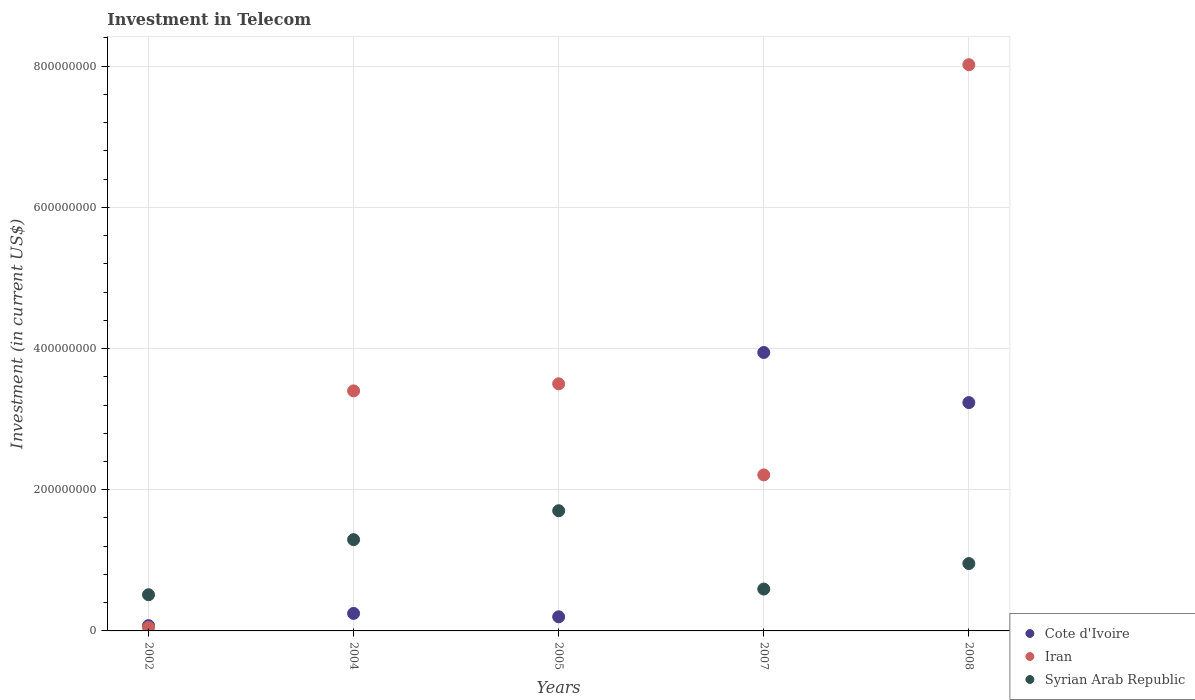How many different coloured dotlines are there?
Your response must be concise. 3. Is the number of dotlines equal to the number of legend labels?
Your answer should be compact. Yes. What is the amount invested in telecom in Cote d'Ivoire in 2002?
Your answer should be very brief. 7.50e+06. Across all years, what is the maximum amount invested in telecom in Iran?
Offer a terse response. 8.02e+08. In which year was the amount invested in telecom in Cote d'Ivoire maximum?
Ensure brevity in your answer.  2007. In which year was the amount invested in telecom in Cote d'Ivoire minimum?
Your response must be concise. 2002. What is the total amount invested in telecom in Syrian Arab Republic in the graph?
Provide a short and direct response. 5.05e+08. What is the difference between the amount invested in telecom in Syrian Arab Republic in 2004 and that in 2005?
Your answer should be compact. -4.10e+07. What is the difference between the amount invested in telecom in Iran in 2004 and the amount invested in telecom in Cote d'Ivoire in 2007?
Provide a short and direct response. -5.44e+07. What is the average amount invested in telecom in Iran per year?
Make the answer very short. 3.44e+08. In the year 2004, what is the difference between the amount invested in telecom in Syrian Arab Republic and amount invested in telecom in Cote d'Ivoire?
Provide a succinct answer. 1.04e+08. In how many years, is the amount invested in telecom in Iran greater than 440000000 US$?
Your answer should be compact. 1. What is the ratio of the amount invested in telecom in Iran in 2005 to that in 2007?
Your answer should be compact. 1.58. Is the amount invested in telecom in Iran in 2002 less than that in 2005?
Offer a terse response. Yes. Is the difference between the amount invested in telecom in Syrian Arab Republic in 2007 and 2008 greater than the difference between the amount invested in telecom in Cote d'Ivoire in 2007 and 2008?
Your answer should be compact. No. What is the difference between the highest and the second highest amount invested in telecom in Iran?
Give a very brief answer. 4.52e+08. What is the difference between the highest and the lowest amount invested in telecom in Cote d'Ivoire?
Your response must be concise. 3.87e+08. Is the sum of the amount invested in telecom in Cote d'Ivoire in 2005 and 2007 greater than the maximum amount invested in telecom in Syrian Arab Republic across all years?
Your response must be concise. Yes. Is it the case that in every year, the sum of the amount invested in telecom in Syrian Arab Republic and amount invested in telecom in Cote d'Ivoire  is greater than the amount invested in telecom in Iran?
Make the answer very short. No. Does the amount invested in telecom in Syrian Arab Republic monotonically increase over the years?
Keep it short and to the point. No. Is the amount invested in telecom in Syrian Arab Republic strictly less than the amount invested in telecom in Iran over the years?
Give a very brief answer. No. How many dotlines are there?
Provide a succinct answer. 3. How many years are there in the graph?
Offer a terse response. 5. Does the graph contain any zero values?
Give a very brief answer. No. Does the graph contain grids?
Your answer should be very brief. Yes. How many legend labels are there?
Give a very brief answer. 3. What is the title of the graph?
Make the answer very short. Investment in Telecom. What is the label or title of the Y-axis?
Offer a very short reply. Investment (in current US$). What is the Investment (in current US$) of Cote d'Ivoire in 2002?
Provide a succinct answer. 7.50e+06. What is the Investment (in current US$) of Syrian Arab Republic in 2002?
Ensure brevity in your answer.  5.12e+07. What is the Investment (in current US$) in Cote d'Ivoire in 2004?
Keep it short and to the point. 2.48e+07. What is the Investment (in current US$) of Iran in 2004?
Provide a short and direct response. 3.40e+08. What is the Investment (in current US$) of Syrian Arab Republic in 2004?
Provide a succinct answer. 1.29e+08. What is the Investment (in current US$) of Cote d'Ivoire in 2005?
Your answer should be very brief. 2.00e+07. What is the Investment (in current US$) of Iran in 2005?
Make the answer very short. 3.50e+08. What is the Investment (in current US$) of Syrian Arab Republic in 2005?
Provide a succinct answer. 1.70e+08. What is the Investment (in current US$) of Cote d'Ivoire in 2007?
Ensure brevity in your answer.  3.94e+08. What is the Investment (in current US$) in Iran in 2007?
Provide a succinct answer. 2.21e+08. What is the Investment (in current US$) of Syrian Arab Republic in 2007?
Your answer should be very brief. 5.93e+07. What is the Investment (in current US$) of Cote d'Ivoire in 2008?
Ensure brevity in your answer.  3.23e+08. What is the Investment (in current US$) in Iran in 2008?
Ensure brevity in your answer.  8.02e+08. What is the Investment (in current US$) of Syrian Arab Republic in 2008?
Ensure brevity in your answer.  9.54e+07. Across all years, what is the maximum Investment (in current US$) of Cote d'Ivoire?
Provide a short and direct response. 3.94e+08. Across all years, what is the maximum Investment (in current US$) of Iran?
Give a very brief answer. 8.02e+08. Across all years, what is the maximum Investment (in current US$) in Syrian Arab Republic?
Provide a succinct answer. 1.70e+08. Across all years, what is the minimum Investment (in current US$) in Cote d'Ivoire?
Your response must be concise. 7.50e+06. Across all years, what is the minimum Investment (in current US$) in Iran?
Your answer should be very brief. 5.00e+06. Across all years, what is the minimum Investment (in current US$) of Syrian Arab Republic?
Ensure brevity in your answer.  5.12e+07. What is the total Investment (in current US$) in Cote d'Ivoire in the graph?
Provide a succinct answer. 7.70e+08. What is the total Investment (in current US$) in Iran in the graph?
Make the answer very short. 1.72e+09. What is the total Investment (in current US$) in Syrian Arab Republic in the graph?
Offer a terse response. 5.05e+08. What is the difference between the Investment (in current US$) in Cote d'Ivoire in 2002 and that in 2004?
Your answer should be compact. -1.73e+07. What is the difference between the Investment (in current US$) of Iran in 2002 and that in 2004?
Your answer should be very brief. -3.35e+08. What is the difference between the Investment (in current US$) in Syrian Arab Republic in 2002 and that in 2004?
Provide a succinct answer. -7.80e+07. What is the difference between the Investment (in current US$) in Cote d'Ivoire in 2002 and that in 2005?
Offer a very short reply. -1.25e+07. What is the difference between the Investment (in current US$) of Iran in 2002 and that in 2005?
Your answer should be compact. -3.45e+08. What is the difference between the Investment (in current US$) in Syrian Arab Republic in 2002 and that in 2005?
Give a very brief answer. -1.19e+08. What is the difference between the Investment (in current US$) in Cote d'Ivoire in 2002 and that in 2007?
Provide a succinct answer. -3.87e+08. What is the difference between the Investment (in current US$) of Iran in 2002 and that in 2007?
Offer a very short reply. -2.16e+08. What is the difference between the Investment (in current US$) in Syrian Arab Republic in 2002 and that in 2007?
Give a very brief answer. -8.05e+06. What is the difference between the Investment (in current US$) in Cote d'Ivoire in 2002 and that in 2008?
Your answer should be very brief. -3.16e+08. What is the difference between the Investment (in current US$) in Iran in 2002 and that in 2008?
Ensure brevity in your answer.  -7.97e+08. What is the difference between the Investment (in current US$) in Syrian Arab Republic in 2002 and that in 2008?
Make the answer very short. -4.42e+07. What is the difference between the Investment (in current US$) in Cote d'Ivoire in 2004 and that in 2005?
Your answer should be very brief. 4.80e+06. What is the difference between the Investment (in current US$) of Iran in 2004 and that in 2005?
Offer a very short reply. -1.00e+07. What is the difference between the Investment (in current US$) in Syrian Arab Republic in 2004 and that in 2005?
Give a very brief answer. -4.10e+07. What is the difference between the Investment (in current US$) in Cote d'Ivoire in 2004 and that in 2007?
Provide a succinct answer. -3.70e+08. What is the difference between the Investment (in current US$) of Iran in 2004 and that in 2007?
Offer a terse response. 1.19e+08. What is the difference between the Investment (in current US$) in Syrian Arab Republic in 2004 and that in 2007?
Your answer should be very brief. 7.00e+07. What is the difference between the Investment (in current US$) of Cote d'Ivoire in 2004 and that in 2008?
Keep it short and to the point. -2.99e+08. What is the difference between the Investment (in current US$) of Iran in 2004 and that in 2008?
Your answer should be very brief. -4.62e+08. What is the difference between the Investment (in current US$) of Syrian Arab Republic in 2004 and that in 2008?
Keep it short and to the point. 3.38e+07. What is the difference between the Investment (in current US$) in Cote d'Ivoire in 2005 and that in 2007?
Offer a very short reply. -3.74e+08. What is the difference between the Investment (in current US$) in Iran in 2005 and that in 2007?
Your response must be concise. 1.29e+08. What is the difference between the Investment (in current US$) of Syrian Arab Republic in 2005 and that in 2007?
Give a very brief answer. 1.11e+08. What is the difference between the Investment (in current US$) in Cote d'Ivoire in 2005 and that in 2008?
Offer a terse response. -3.03e+08. What is the difference between the Investment (in current US$) in Iran in 2005 and that in 2008?
Your answer should be compact. -4.52e+08. What is the difference between the Investment (in current US$) of Syrian Arab Republic in 2005 and that in 2008?
Provide a succinct answer. 7.48e+07. What is the difference between the Investment (in current US$) in Cote d'Ivoire in 2007 and that in 2008?
Provide a succinct answer. 7.10e+07. What is the difference between the Investment (in current US$) of Iran in 2007 and that in 2008?
Your answer should be very brief. -5.81e+08. What is the difference between the Investment (in current US$) of Syrian Arab Republic in 2007 and that in 2008?
Make the answer very short. -3.61e+07. What is the difference between the Investment (in current US$) of Cote d'Ivoire in 2002 and the Investment (in current US$) of Iran in 2004?
Offer a very short reply. -3.32e+08. What is the difference between the Investment (in current US$) in Cote d'Ivoire in 2002 and the Investment (in current US$) in Syrian Arab Republic in 2004?
Your response must be concise. -1.22e+08. What is the difference between the Investment (in current US$) in Iran in 2002 and the Investment (in current US$) in Syrian Arab Republic in 2004?
Your answer should be compact. -1.24e+08. What is the difference between the Investment (in current US$) in Cote d'Ivoire in 2002 and the Investment (in current US$) in Iran in 2005?
Ensure brevity in your answer.  -3.42e+08. What is the difference between the Investment (in current US$) in Cote d'Ivoire in 2002 and the Investment (in current US$) in Syrian Arab Republic in 2005?
Offer a very short reply. -1.63e+08. What is the difference between the Investment (in current US$) of Iran in 2002 and the Investment (in current US$) of Syrian Arab Republic in 2005?
Offer a terse response. -1.65e+08. What is the difference between the Investment (in current US$) in Cote d'Ivoire in 2002 and the Investment (in current US$) in Iran in 2007?
Your response must be concise. -2.14e+08. What is the difference between the Investment (in current US$) of Cote d'Ivoire in 2002 and the Investment (in current US$) of Syrian Arab Republic in 2007?
Offer a very short reply. -5.18e+07. What is the difference between the Investment (in current US$) in Iran in 2002 and the Investment (in current US$) in Syrian Arab Republic in 2007?
Provide a short and direct response. -5.43e+07. What is the difference between the Investment (in current US$) in Cote d'Ivoire in 2002 and the Investment (in current US$) in Iran in 2008?
Your answer should be very brief. -7.94e+08. What is the difference between the Investment (in current US$) of Cote d'Ivoire in 2002 and the Investment (in current US$) of Syrian Arab Republic in 2008?
Provide a succinct answer. -8.79e+07. What is the difference between the Investment (in current US$) in Iran in 2002 and the Investment (in current US$) in Syrian Arab Republic in 2008?
Your answer should be very brief. -9.04e+07. What is the difference between the Investment (in current US$) in Cote d'Ivoire in 2004 and the Investment (in current US$) in Iran in 2005?
Offer a very short reply. -3.25e+08. What is the difference between the Investment (in current US$) of Cote d'Ivoire in 2004 and the Investment (in current US$) of Syrian Arab Republic in 2005?
Offer a very short reply. -1.45e+08. What is the difference between the Investment (in current US$) in Iran in 2004 and the Investment (in current US$) in Syrian Arab Republic in 2005?
Your answer should be very brief. 1.70e+08. What is the difference between the Investment (in current US$) of Cote d'Ivoire in 2004 and the Investment (in current US$) of Iran in 2007?
Your response must be concise. -1.96e+08. What is the difference between the Investment (in current US$) in Cote d'Ivoire in 2004 and the Investment (in current US$) in Syrian Arab Republic in 2007?
Offer a terse response. -3.45e+07. What is the difference between the Investment (in current US$) of Iran in 2004 and the Investment (in current US$) of Syrian Arab Republic in 2007?
Offer a terse response. 2.81e+08. What is the difference between the Investment (in current US$) of Cote d'Ivoire in 2004 and the Investment (in current US$) of Iran in 2008?
Keep it short and to the point. -7.77e+08. What is the difference between the Investment (in current US$) in Cote d'Ivoire in 2004 and the Investment (in current US$) in Syrian Arab Republic in 2008?
Your response must be concise. -7.06e+07. What is the difference between the Investment (in current US$) of Iran in 2004 and the Investment (in current US$) of Syrian Arab Republic in 2008?
Give a very brief answer. 2.45e+08. What is the difference between the Investment (in current US$) of Cote d'Ivoire in 2005 and the Investment (in current US$) of Iran in 2007?
Ensure brevity in your answer.  -2.01e+08. What is the difference between the Investment (in current US$) of Cote d'Ivoire in 2005 and the Investment (in current US$) of Syrian Arab Republic in 2007?
Ensure brevity in your answer.  -3.93e+07. What is the difference between the Investment (in current US$) of Iran in 2005 and the Investment (in current US$) of Syrian Arab Republic in 2007?
Offer a terse response. 2.91e+08. What is the difference between the Investment (in current US$) in Cote d'Ivoire in 2005 and the Investment (in current US$) in Iran in 2008?
Offer a terse response. -7.82e+08. What is the difference between the Investment (in current US$) of Cote d'Ivoire in 2005 and the Investment (in current US$) of Syrian Arab Republic in 2008?
Provide a succinct answer. -7.54e+07. What is the difference between the Investment (in current US$) in Iran in 2005 and the Investment (in current US$) in Syrian Arab Republic in 2008?
Your answer should be very brief. 2.55e+08. What is the difference between the Investment (in current US$) in Cote d'Ivoire in 2007 and the Investment (in current US$) in Iran in 2008?
Make the answer very short. -4.08e+08. What is the difference between the Investment (in current US$) in Cote d'Ivoire in 2007 and the Investment (in current US$) in Syrian Arab Republic in 2008?
Ensure brevity in your answer.  2.99e+08. What is the difference between the Investment (in current US$) in Iran in 2007 and the Investment (in current US$) in Syrian Arab Republic in 2008?
Provide a succinct answer. 1.26e+08. What is the average Investment (in current US$) in Cote d'Ivoire per year?
Provide a succinct answer. 1.54e+08. What is the average Investment (in current US$) of Iran per year?
Offer a terse response. 3.44e+08. What is the average Investment (in current US$) in Syrian Arab Republic per year?
Make the answer very short. 1.01e+08. In the year 2002, what is the difference between the Investment (in current US$) of Cote d'Ivoire and Investment (in current US$) of Iran?
Your answer should be very brief. 2.50e+06. In the year 2002, what is the difference between the Investment (in current US$) in Cote d'Ivoire and Investment (in current US$) in Syrian Arab Republic?
Offer a very short reply. -4.38e+07. In the year 2002, what is the difference between the Investment (in current US$) of Iran and Investment (in current US$) of Syrian Arab Republic?
Provide a succinct answer. -4.62e+07. In the year 2004, what is the difference between the Investment (in current US$) of Cote d'Ivoire and Investment (in current US$) of Iran?
Make the answer very short. -3.15e+08. In the year 2004, what is the difference between the Investment (in current US$) in Cote d'Ivoire and Investment (in current US$) in Syrian Arab Republic?
Keep it short and to the point. -1.04e+08. In the year 2004, what is the difference between the Investment (in current US$) of Iran and Investment (in current US$) of Syrian Arab Republic?
Give a very brief answer. 2.11e+08. In the year 2005, what is the difference between the Investment (in current US$) of Cote d'Ivoire and Investment (in current US$) of Iran?
Offer a very short reply. -3.30e+08. In the year 2005, what is the difference between the Investment (in current US$) of Cote d'Ivoire and Investment (in current US$) of Syrian Arab Republic?
Provide a short and direct response. -1.50e+08. In the year 2005, what is the difference between the Investment (in current US$) of Iran and Investment (in current US$) of Syrian Arab Republic?
Your answer should be compact. 1.80e+08. In the year 2007, what is the difference between the Investment (in current US$) of Cote d'Ivoire and Investment (in current US$) of Iran?
Your response must be concise. 1.73e+08. In the year 2007, what is the difference between the Investment (in current US$) in Cote d'Ivoire and Investment (in current US$) in Syrian Arab Republic?
Make the answer very short. 3.35e+08. In the year 2007, what is the difference between the Investment (in current US$) in Iran and Investment (in current US$) in Syrian Arab Republic?
Your answer should be very brief. 1.62e+08. In the year 2008, what is the difference between the Investment (in current US$) of Cote d'Ivoire and Investment (in current US$) of Iran?
Your answer should be very brief. -4.79e+08. In the year 2008, what is the difference between the Investment (in current US$) of Cote d'Ivoire and Investment (in current US$) of Syrian Arab Republic?
Provide a short and direct response. 2.28e+08. In the year 2008, what is the difference between the Investment (in current US$) of Iran and Investment (in current US$) of Syrian Arab Republic?
Ensure brevity in your answer.  7.07e+08. What is the ratio of the Investment (in current US$) in Cote d'Ivoire in 2002 to that in 2004?
Keep it short and to the point. 0.3. What is the ratio of the Investment (in current US$) in Iran in 2002 to that in 2004?
Offer a very short reply. 0.01. What is the ratio of the Investment (in current US$) of Syrian Arab Republic in 2002 to that in 2004?
Your answer should be compact. 0.4. What is the ratio of the Investment (in current US$) of Iran in 2002 to that in 2005?
Ensure brevity in your answer.  0.01. What is the ratio of the Investment (in current US$) in Syrian Arab Republic in 2002 to that in 2005?
Offer a terse response. 0.3. What is the ratio of the Investment (in current US$) in Cote d'Ivoire in 2002 to that in 2007?
Offer a terse response. 0.02. What is the ratio of the Investment (in current US$) of Iran in 2002 to that in 2007?
Offer a very short reply. 0.02. What is the ratio of the Investment (in current US$) in Syrian Arab Republic in 2002 to that in 2007?
Your answer should be very brief. 0.86. What is the ratio of the Investment (in current US$) of Cote d'Ivoire in 2002 to that in 2008?
Provide a succinct answer. 0.02. What is the ratio of the Investment (in current US$) in Iran in 2002 to that in 2008?
Your answer should be very brief. 0.01. What is the ratio of the Investment (in current US$) in Syrian Arab Republic in 2002 to that in 2008?
Ensure brevity in your answer.  0.54. What is the ratio of the Investment (in current US$) in Cote d'Ivoire in 2004 to that in 2005?
Ensure brevity in your answer.  1.24. What is the ratio of the Investment (in current US$) of Iran in 2004 to that in 2005?
Ensure brevity in your answer.  0.97. What is the ratio of the Investment (in current US$) of Syrian Arab Republic in 2004 to that in 2005?
Give a very brief answer. 0.76. What is the ratio of the Investment (in current US$) of Cote d'Ivoire in 2004 to that in 2007?
Your answer should be compact. 0.06. What is the ratio of the Investment (in current US$) of Iran in 2004 to that in 2007?
Provide a short and direct response. 1.54. What is the ratio of the Investment (in current US$) of Syrian Arab Republic in 2004 to that in 2007?
Your answer should be very brief. 2.18. What is the ratio of the Investment (in current US$) in Cote d'Ivoire in 2004 to that in 2008?
Make the answer very short. 0.08. What is the ratio of the Investment (in current US$) of Iran in 2004 to that in 2008?
Ensure brevity in your answer.  0.42. What is the ratio of the Investment (in current US$) of Syrian Arab Republic in 2004 to that in 2008?
Your answer should be compact. 1.35. What is the ratio of the Investment (in current US$) in Cote d'Ivoire in 2005 to that in 2007?
Keep it short and to the point. 0.05. What is the ratio of the Investment (in current US$) of Iran in 2005 to that in 2007?
Offer a terse response. 1.58. What is the ratio of the Investment (in current US$) of Syrian Arab Republic in 2005 to that in 2007?
Offer a very short reply. 2.87. What is the ratio of the Investment (in current US$) of Cote d'Ivoire in 2005 to that in 2008?
Your answer should be compact. 0.06. What is the ratio of the Investment (in current US$) of Iran in 2005 to that in 2008?
Offer a very short reply. 0.44. What is the ratio of the Investment (in current US$) of Syrian Arab Republic in 2005 to that in 2008?
Offer a very short reply. 1.78. What is the ratio of the Investment (in current US$) in Cote d'Ivoire in 2007 to that in 2008?
Give a very brief answer. 1.22. What is the ratio of the Investment (in current US$) of Iran in 2007 to that in 2008?
Make the answer very short. 0.28. What is the ratio of the Investment (in current US$) of Syrian Arab Republic in 2007 to that in 2008?
Offer a terse response. 0.62. What is the difference between the highest and the second highest Investment (in current US$) in Cote d'Ivoire?
Ensure brevity in your answer.  7.10e+07. What is the difference between the highest and the second highest Investment (in current US$) in Iran?
Provide a succinct answer. 4.52e+08. What is the difference between the highest and the second highest Investment (in current US$) of Syrian Arab Republic?
Keep it short and to the point. 4.10e+07. What is the difference between the highest and the lowest Investment (in current US$) of Cote d'Ivoire?
Your answer should be compact. 3.87e+08. What is the difference between the highest and the lowest Investment (in current US$) in Iran?
Provide a succinct answer. 7.97e+08. What is the difference between the highest and the lowest Investment (in current US$) in Syrian Arab Republic?
Your response must be concise. 1.19e+08. 